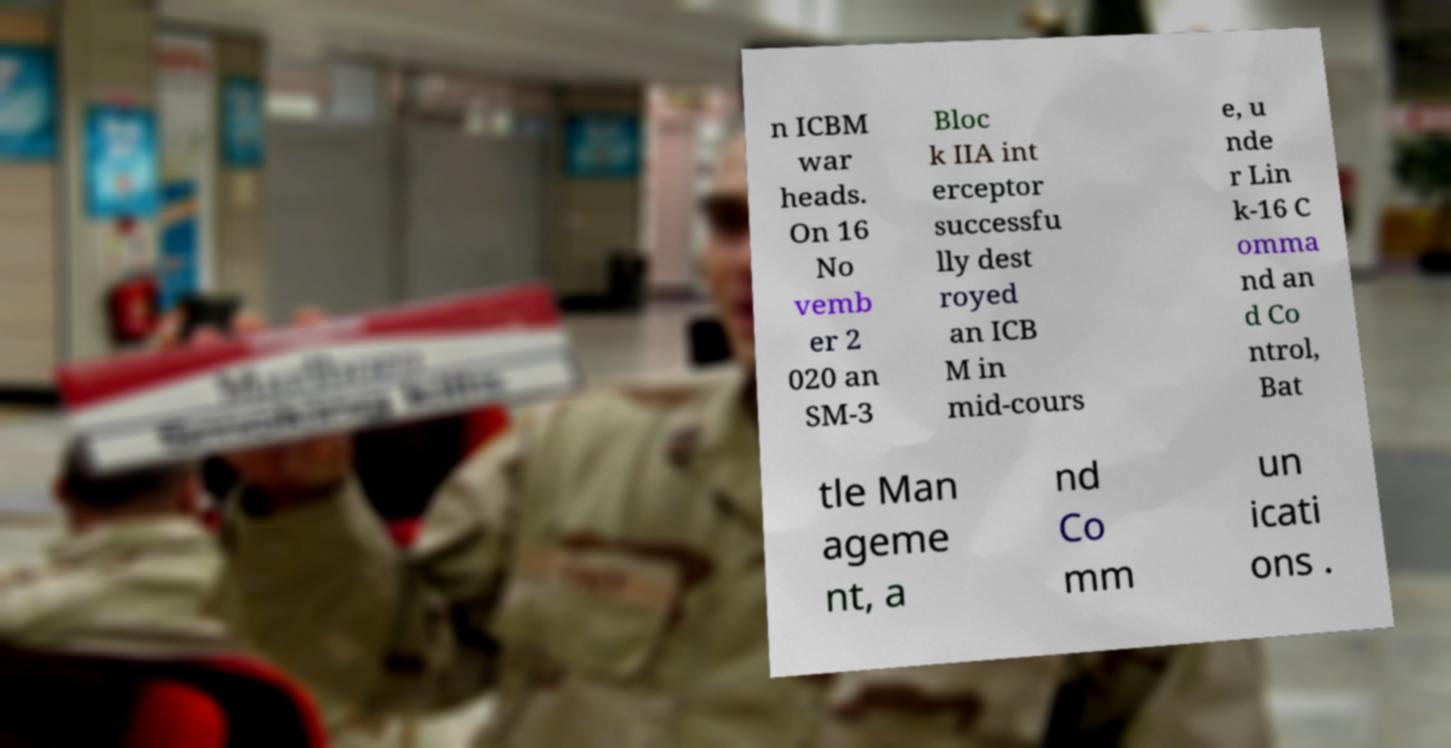Could you assist in decoding the text presented in this image and type it out clearly? n ICBM war heads. On 16 No vemb er 2 020 an SM-3 Bloc k IIA int erceptor successfu lly dest royed an ICB M in mid-cours e, u nde r Lin k-16 C omma nd an d Co ntrol, Bat tle Man ageme nt, a nd Co mm un icati ons . 